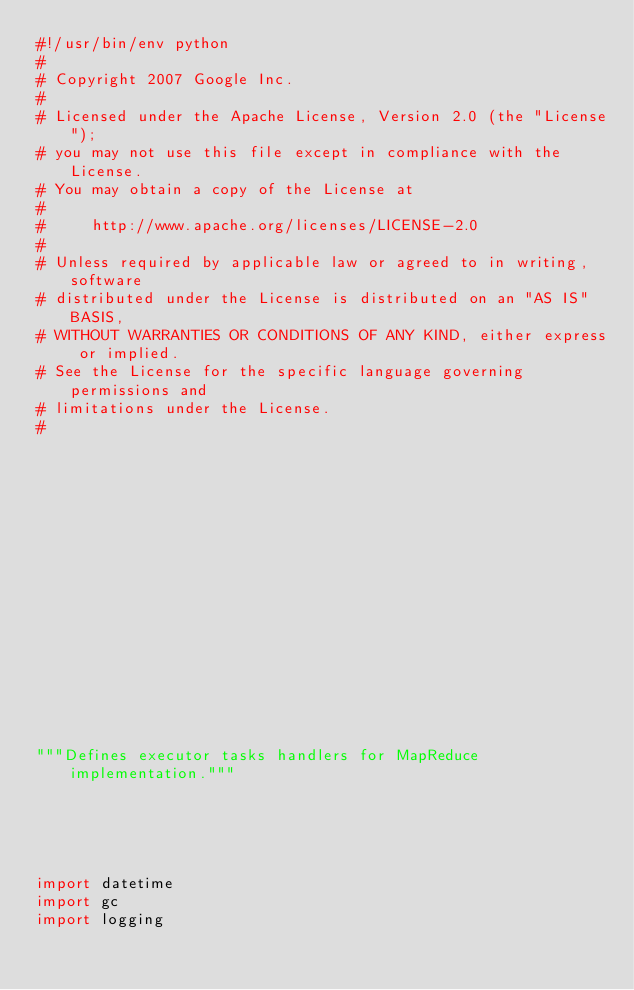<code> <loc_0><loc_0><loc_500><loc_500><_Python_>#!/usr/bin/env python
#
# Copyright 2007 Google Inc.
#
# Licensed under the Apache License, Version 2.0 (the "License");
# you may not use this file except in compliance with the License.
# You may obtain a copy of the License at
#
#     http://www.apache.org/licenses/LICENSE-2.0
#
# Unless required by applicable law or agreed to in writing, software
# distributed under the License is distributed on an "AS IS" BASIS,
# WITHOUT WARRANTIES OR CONDITIONS OF ANY KIND, either express or implied.
# See the License for the specific language governing permissions and
# limitations under the License.
#

















"""Defines executor tasks handlers for MapReduce implementation."""





import datetime
import gc
import logging</code> 